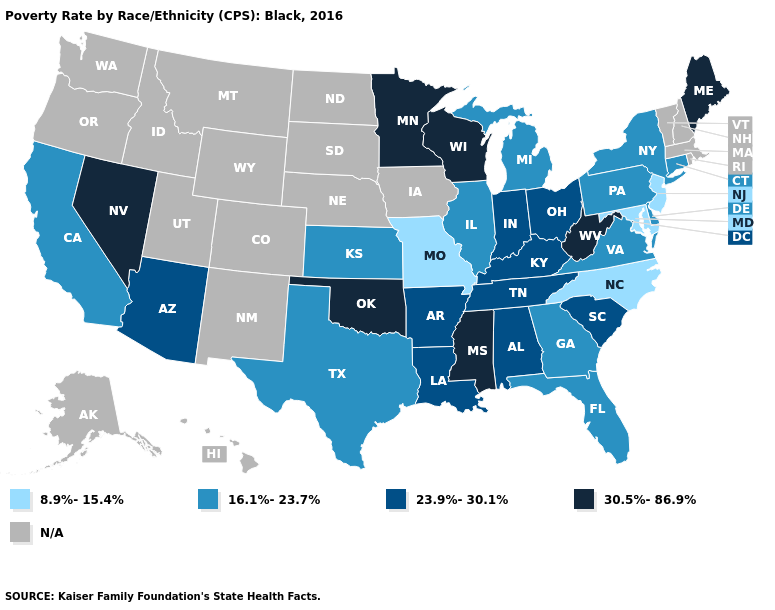Does New Jersey have the lowest value in the USA?
Short answer required. Yes. What is the lowest value in the MidWest?
Answer briefly. 8.9%-15.4%. How many symbols are there in the legend?
Be succinct. 5. Does Arizona have the highest value in the West?
Give a very brief answer. No. What is the value of Wyoming?
Write a very short answer. N/A. Which states have the highest value in the USA?
Concise answer only. Maine, Minnesota, Mississippi, Nevada, Oklahoma, West Virginia, Wisconsin. Name the states that have a value in the range N/A?
Quick response, please. Alaska, Colorado, Hawaii, Idaho, Iowa, Massachusetts, Montana, Nebraska, New Hampshire, New Mexico, North Dakota, Oregon, Rhode Island, South Dakota, Utah, Vermont, Washington, Wyoming. Does Minnesota have the highest value in the MidWest?
Concise answer only. Yes. What is the value of Georgia?
Keep it brief. 16.1%-23.7%. What is the value of Oregon?
Keep it brief. N/A. Which states hav the highest value in the MidWest?
Short answer required. Minnesota, Wisconsin. Does New Jersey have the highest value in the Northeast?
Keep it brief. No. What is the highest value in the USA?
Concise answer only. 30.5%-86.9%. 